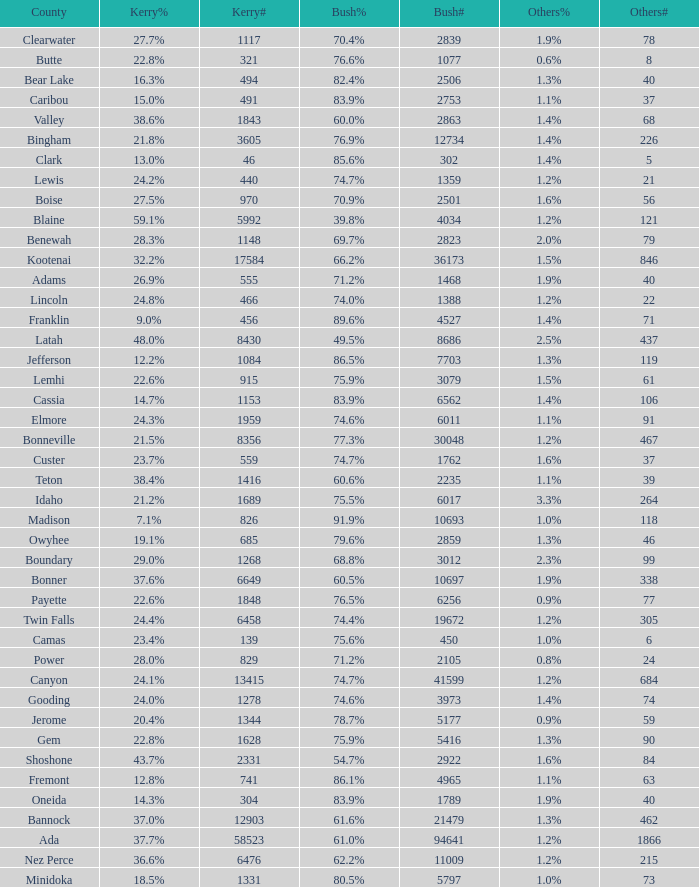What percentage of the votes in Oneida did Kerry win? 14.3%. 